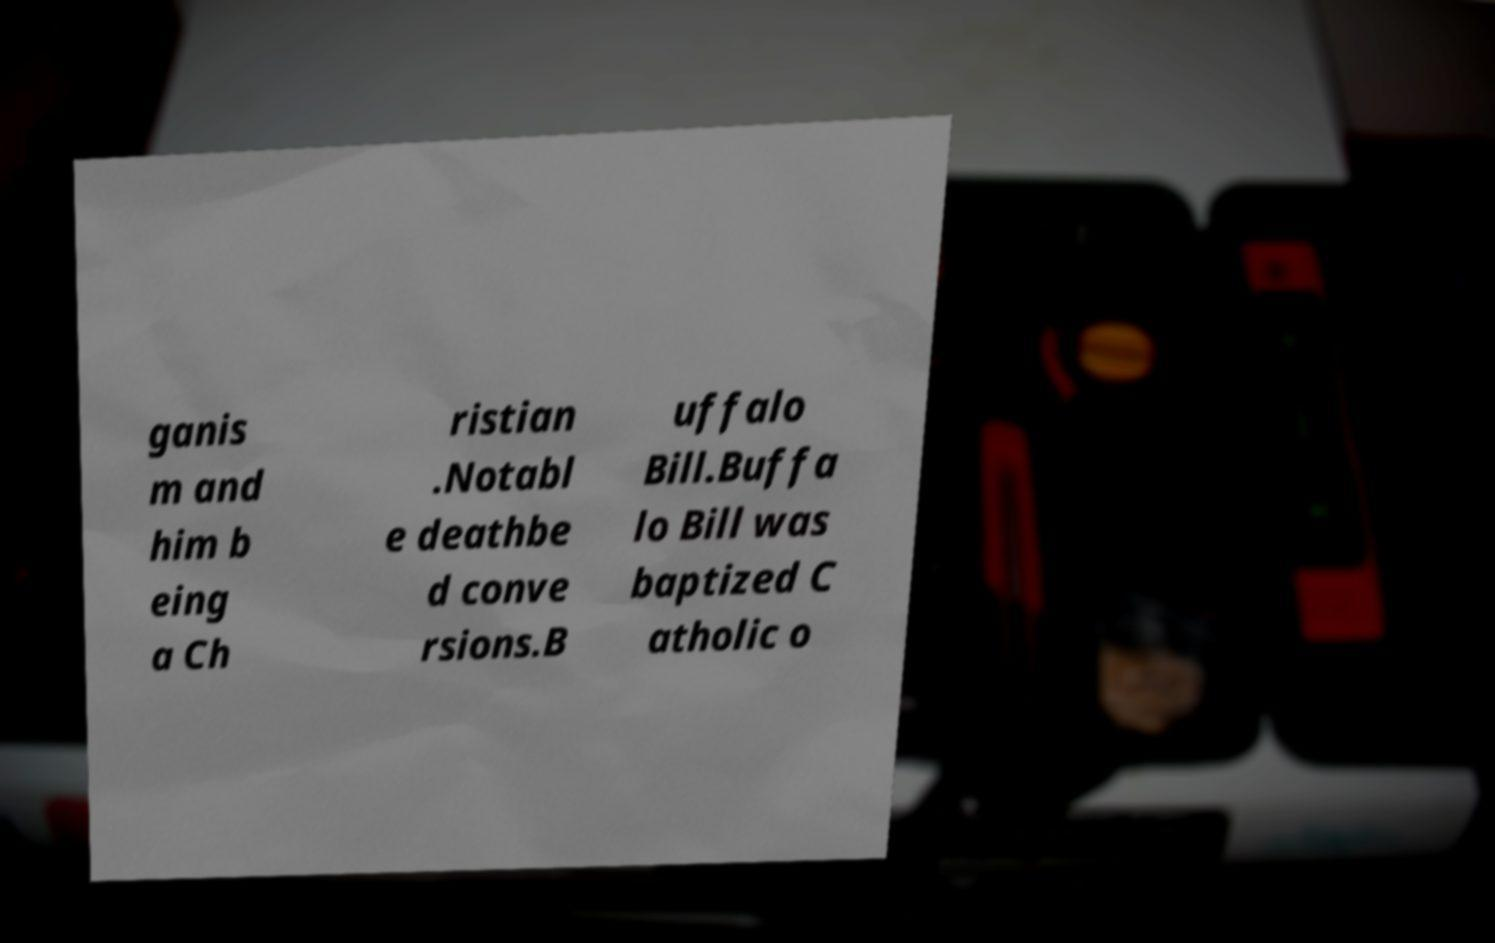Could you assist in decoding the text presented in this image and type it out clearly? ganis m and him b eing a Ch ristian .Notabl e deathbe d conve rsions.B uffalo Bill.Buffa lo Bill was baptized C atholic o 